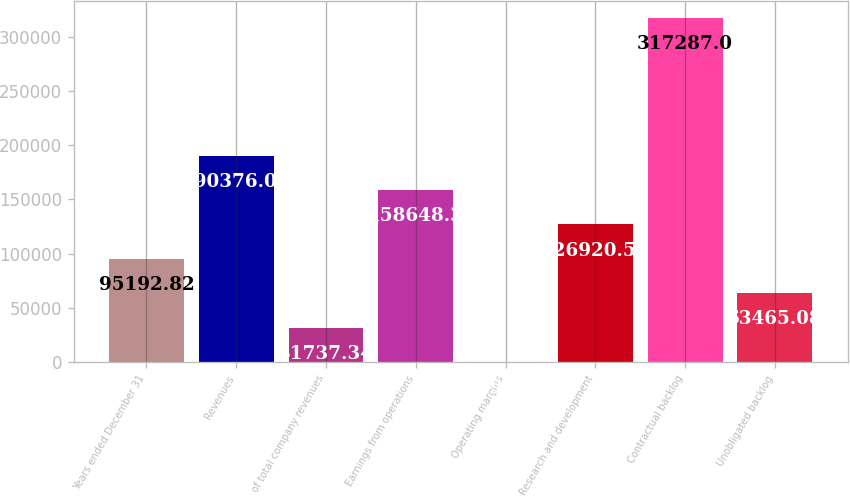Convert chart. <chart><loc_0><loc_0><loc_500><loc_500><bar_chart><fcel>Years ended December 31<fcel>Revenues<fcel>of total company revenues<fcel>Earnings from operations<fcel>Operating margins<fcel>Research and development<fcel>Contractual backlog<fcel>Unobligated backlog<nl><fcel>95192.8<fcel>190376<fcel>31737.3<fcel>158648<fcel>9.6<fcel>126921<fcel>317287<fcel>63465.1<nl></chart> 